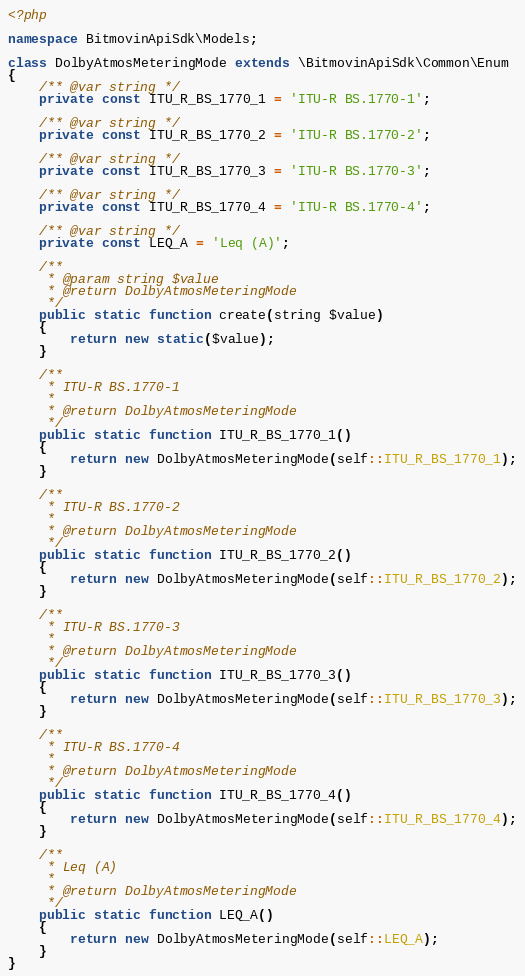<code> <loc_0><loc_0><loc_500><loc_500><_PHP_><?php

namespace BitmovinApiSdk\Models;

class DolbyAtmosMeteringMode extends \BitmovinApiSdk\Common\Enum
{
    /** @var string */
    private const ITU_R_BS_1770_1 = 'ITU-R BS.1770-1';

    /** @var string */
    private const ITU_R_BS_1770_2 = 'ITU-R BS.1770-2';

    /** @var string */
    private const ITU_R_BS_1770_3 = 'ITU-R BS.1770-3';

    /** @var string */
    private const ITU_R_BS_1770_4 = 'ITU-R BS.1770-4';

    /** @var string */
    private const LEQ_A = 'Leq (A)';

    /**
     * @param string $value
     * @return DolbyAtmosMeteringMode
     */
    public static function create(string $value)
    {
        return new static($value);
    }

    /**
     * ITU-R BS.1770-1
     *
     * @return DolbyAtmosMeteringMode
     */
    public static function ITU_R_BS_1770_1()
    {
        return new DolbyAtmosMeteringMode(self::ITU_R_BS_1770_1);
    }

    /**
     * ITU-R BS.1770-2
     *
     * @return DolbyAtmosMeteringMode
     */
    public static function ITU_R_BS_1770_2()
    {
        return new DolbyAtmosMeteringMode(self::ITU_R_BS_1770_2);
    }

    /**
     * ITU-R BS.1770-3
     *
     * @return DolbyAtmosMeteringMode
     */
    public static function ITU_R_BS_1770_3()
    {
        return new DolbyAtmosMeteringMode(self::ITU_R_BS_1770_3);
    }

    /**
     * ITU-R BS.1770-4
     *
     * @return DolbyAtmosMeteringMode
     */
    public static function ITU_R_BS_1770_4()
    {
        return new DolbyAtmosMeteringMode(self::ITU_R_BS_1770_4);
    }

    /**
     * Leq (A)
     *
     * @return DolbyAtmosMeteringMode
     */
    public static function LEQ_A()
    {
        return new DolbyAtmosMeteringMode(self::LEQ_A);
    }
}

</code> 